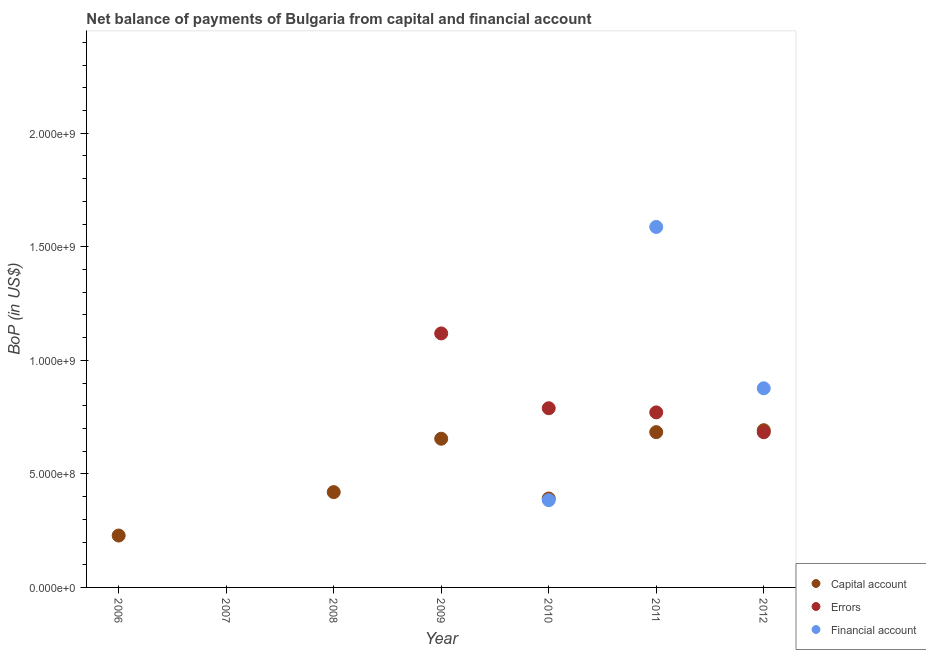Is the number of dotlines equal to the number of legend labels?
Give a very brief answer. No. What is the amount of financial account in 2011?
Provide a short and direct response. 1.59e+09. Across all years, what is the maximum amount of net capital account?
Your answer should be very brief. 6.92e+08. What is the total amount of financial account in the graph?
Ensure brevity in your answer.  2.85e+09. What is the difference between the amount of errors in 2009 and that in 2012?
Give a very brief answer. 4.35e+08. What is the difference between the amount of net capital account in 2011 and the amount of financial account in 2006?
Offer a very short reply. 6.84e+08. What is the average amount of financial account per year?
Your answer should be very brief. 4.07e+08. In the year 2010, what is the difference between the amount of net capital account and amount of errors?
Your response must be concise. -3.98e+08. What is the ratio of the amount of errors in 2009 to that in 2010?
Your answer should be compact. 1.42. Is the difference between the amount of errors in 2009 and 2010 greater than the difference between the amount of net capital account in 2009 and 2010?
Offer a very short reply. Yes. What is the difference between the highest and the second highest amount of financial account?
Keep it short and to the point. 7.10e+08. What is the difference between the highest and the lowest amount of net capital account?
Provide a succinct answer. 6.92e+08. Is the amount of net capital account strictly less than the amount of financial account over the years?
Your response must be concise. No. How many dotlines are there?
Make the answer very short. 3. Are the values on the major ticks of Y-axis written in scientific E-notation?
Keep it short and to the point. Yes. Does the graph contain any zero values?
Your answer should be compact. Yes. Does the graph contain grids?
Offer a very short reply. No. Where does the legend appear in the graph?
Keep it short and to the point. Bottom right. How many legend labels are there?
Provide a short and direct response. 3. How are the legend labels stacked?
Make the answer very short. Vertical. What is the title of the graph?
Your response must be concise. Net balance of payments of Bulgaria from capital and financial account. What is the label or title of the X-axis?
Make the answer very short. Year. What is the label or title of the Y-axis?
Offer a terse response. BoP (in US$). What is the BoP (in US$) in Capital account in 2006?
Give a very brief answer. 2.28e+08. What is the BoP (in US$) of Errors in 2006?
Provide a short and direct response. 0. What is the BoP (in US$) in Errors in 2007?
Provide a succinct answer. 0. What is the BoP (in US$) in Capital account in 2008?
Your answer should be compact. 4.20e+08. What is the BoP (in US$) of Capital account in 2009?
Your response must be concise. 6.55e+08. What is the BoP (in US$) in Errors in 2009?
Your response must be concise. 1.12e+09. What is the BoP (in US$) in Financial account in 2009?
Offer a terse response. 0. What is the BoP (in US$) in Capital account in 2010?
Offer a very short reply. 3.91e+08. What is the BoP (in US$) of Errors in 2010?
Ensure brevity in your answer.  7.89e+08. What is the BoP (in US$) of Financial account in 2010?
Offer a terse response. 3.84e+08. What is the BoP (in US$) in Capital account in 2011?
Give a very brief answer. 6.84e+08. What is the BoP (in US$) in Errors in 2011?
Your response must be concise. 7.71e+08. What is the BoP (in US$) in Financial account in 2011?
Give a very brief answer. 1.59e+09. What is the BoP (in US$) of Capital account in 2012?
Provide a short and direct response. 6.92e+08. What is the BoP (in US$) in Errors in 2012?
Keep it short and to the point. 6.83e+08. What is the BoP (in US$) in Financial account in 2012?
Offer a very short reply. 8.77e+08. Across all years, what is the maximum BoP (in US$) of Capital account?
Give a very brief answer. 6.92e+08. Across all years, what is the maximum BoP (in US$) of Errors?
Your answer should be compact. 1.12e+09. Across all years, what is the maximum BoP (in US$) in Financial account?
Offer a very short reply. 1.59e+09. Across all years, what is the minimum BoP (in US$) of Capital account?
Give a very brief answer. 0. What is the total BoP (in US$) of Capital account in the graph?
Offer a very short reply. 3.07e+09. What is the total BoP (in US$) in Errors in the graph?
Your answer should be compact. 3.36e+09. What is the total BoP (in US$) of Financial account in the graph?
Give a very brief answer. 2.85e+09. What is the difference between the BoP (in US$) in Capital account in 2006 and that in 2008?
Your answer should be very brief. -1.91e+08. What is the difference between the BoP (in US$) in Capital account in 2006 and that in 2009?
Provide a succinct answer. -4.26e+08. What is the difference between the BoP (in US$) in Capital account in 2006 and that in 2010?
Offer a very short reply. -1.63e+08. What is the difference between the BoP (in US$) of Capital account in 2006 and that in 2011?
Provide a succinct answer. -4.55e+08. What is the difference between the BoP (in US$) of Capital account in 2006 and that in 2012?
Provide a short and direct response. -4.64e+08. What is the difference between the BoP (in US$) of Capital account in 2008 and that in 2009?
Offer a very short reply. -2.35e+08. What is the difference between the BoP (in US$) in Capital account in 2008 and that in 2010?
Ensure brevity in your answer.  2.82e+07. What is the difference between the BoP (in US$) of Capital account in 2008 and that in 2011?
Make the answer very short. -2.64e+08. What is the difference between the BoP (in US$) in Capital account in 2008 and that in 2012?
Make the answer very short. -2.73e+08. What is the difference between the BoP (in US$) of Capital account in 2009 and that in 2010?
Offer a terse response. 2.63e+08. What is the difference between the BoP (in US$) in Errors in 2009 and that in 2010?
Keep it short and to the point. 3.29e+08. What is the difference between the BoP (in US$) in Capital account in 2009 and that in 2011?
Offer a very short reply. -2.90e+07. What is the difference between the BoP (in US$) in Errors in 2009 and that in 2011?
Keep it short and to the point. 3.48e+08. What is the difference between the BoP (in US$) of Capital account in 2009 and that in 2012?
Your answer should be very brief. -3.75e+07. What is the difference between the BoP (in US$) in Errors in 2009 and that in 2012?
Your response must be concise. 4.35e+08. What is the difference between the BoP (in US$) of Capital account in 2010 and that in 2011?
Provide a succinct answer. -2.92e+08. What is the difference between the BoP (in US$) of Errors in 2010 and that in 2011?
Your answer should be compact. 1.83e+07. What is the difference between the BoP (in US$) in Financial account in 2010 and that in 2011?
Ensure brevity in your answer.  -1.20e+09. What is the difference between the BoP (in US$) of Capital account in 2010 and that in 2012?
Provide a short and direct response. -3.01e+08. What is the difference between the BoP (in US$) of Errors in 2010 and that in 2012?
Keep it short and to the point. 1.06e+08. What is the difference between the BoP (in US$) of Financial account in 2010 and that in 2012?
Provide a short and direct response. -4.93e+08. What is the difference between the BoP (in US$) of Capital account in 2011 and that in 2012?
Your response must be concise. -8.50e+06. What is the difference between the BoP (in US$) of Errors in 2011 and that in 2012?
Your response must be concise. 8.74e+07. What is the difference between the BoP (in US$) in Financial account in 2011 and that in 2012?
Offer a very short reply. 7.10e+08. What is the difference between the BoP (in US$) of Capital account in 2006 and the BoP (in US$) of Errors in 2009?
Give a very brief answer. -8.90e+08. What is the difference between the BoP (in US$) of Capital account in 2006 and the BoP (in US$) of Errors in 2010?
Your response must be concise. -5.61e+08. What is the difference between the BoP (in US$) of Capital account in 2006 and the BoP (in US$) of Financial account in 2010?
Offer a very short reply. -1.56e+08. What is the difference between the BoP (in US$) in Capital account in 2006 and the BoP (in US$) in Errors in 2011?
Your response must be concise. -5.42e+08. What is the difference between the BoP (in US$) of Capital account in 2006 and the BoP (in US$) of Financial account in 2011?
Offer a very short reply. -1.36e+09. What is the difference between the BoP (in US$) of Capital account in 2006 and the BoP (in US$) of Errors in 2012?
Make the answer very short. -4.55e+08. What is the difference between the BoP (in US$) in Capital account in 2006 and the BoP (in US$) in Financial account in 2012?
Ensure brevity in your answer.  -6.48e+08. What is the difference between the BoP (in US$) in Capital account in 2008 and the BoP (in US$) in Errors in 2009?
Provide a succinct answer. -6.99e+08. What is the difference between the BoP (in US$) of Capital account in 2008 and the BoP (in US$) of Errors in 2010?
Ensure brevity in your answer.  -3.69e+08. What is the difference between the BoP (in US$) in Capital account in 2008 and the BoP (in US$) in Financial account in 2010?
Keep it short and to the point. 3.55e+07. What is the difference between the BoP (in US$) in Capital account in 2008 and the BoP (in US$) in Errors in 2011?
Offer a very short reply. -3.51e+08. What is the difference between the BoP (in US$) in Capital account in 2008 and the BoP (in US$) in Financial account in 2011?
Ensure brevity in your answer.  -1.17e+09. What is the difference between the BoP (in US$) in Capital account in 2008 and the BoP (in US$) in Errors in 2012?
Your response must be concise. -2.64e+08. What is the difference between the BoP (in US$) in Capital account in 2008 and the BoP (in US$) in Financial account in 2012?
Make the answer very short. -4.57e+08. What is the difference between the BoP (in US$) of Capital account in 2009 and the BoP (in US$) of Errors in 2010?
Make the answer very short. -1.34e+08. What is the difference between the BoP (in US$) in Capital account in 2009 and the BoP (in US$) in Financial account in 2010?
Your answer should be compact. 2.71e+08. What is the difference between the BoP (in US$) in Errors in 2009 and the BoP (in US$) in Financial account in 2010?
Give a very brief answer. 7.34e+08. What is the difference between the BoP (in US$) in Capital account in 2009 and the BoP (in US$) in Errors in 2011?
Offer a very short reply. -1.16e+08. What is the difference between the BoP (in US$) in Capital account in 2009 and the BoP (in US$) in Financial account in 2011?
Provide a succinct answer. -9.32e+08. What is the difference between the BoP (in US$) in Errors in 2009 and the BoP (in US$) in Financial account in 2011?
Your answer should be very brief. -4.69e+08. What is the difference between the BoP (in US$) in Capital account in 2009 and the BoP (in US$) in Errors in 2012?
Ensure brevity in your answer.  -2.86e+07. What is the difference between the BoP (in US$) in Capital account in 2009 and the BoP (in US$) in Financial account in 2012?
Your answer should be compact. -2.22e+08. What is the difference between the BoP (in US$) of Errors in 2009 and the BoP (in US$) of Financial account in 2012?
Make the answer very short. 2.42e+08. What is the difference between the BoP (in US$) of Capital account in 2010 and the BoP (in US$) of Errors in 2011?
Provide a short and direct response. -3.79e+08. What is the difference between the BoP (in US$) of Capital account in 2010 and the BoP (in US$) of Financial account in 2011?
Offer a terse response. -1.20e+09. What is the difference between the BoP (in US$) of Errors in 2010 and the BoP (in US$) of Financial account in 2011?
Offer a terse response. -7.98e+08. What is the difference between the BoP (in US$) in Capital account in 2010 and the BoP (in US$) in Errors in 2012?
Offer a very short reply. -2.92e+08. What is the difference between the BoP (in US$) in Capital account in 2010 and the BoP (in US$) in Financial account in 2012?
Your answer should be very brief. -4.85e+08. What is the difference between the BoP (in US$) in Errors in 2010 and the BoP (in US$) in Financial account in 2012?
Offer a terse response. -8.78e+07. What is the difference between the BoP (in US$) in Capital account in 2011 and the BoP (in US$) in Errors in 2012?
Your answer should be compact. 4.59e+05. What is the difference between the BoP (in US$) of Capital account in 2011 and the BoP (in US$) of Financial account in 2012?
Provide a short and direct response. -1.93e+08. What is the difference between the BoP (in US$) of Errors in 2011 and the BoP (in US$) of Financial account in 2012?
Offer a terse response. -1.06e+08. What is the average BoP (in US$) of Capital account per year?
Offer a terse response. 4.39e+08. What is the average BoP (in US$) of Errors per year?
Your response must be concise. 4.80e+08. What is the average BoP (in US$) of Financial account per year?
Offer a terse response. 4.07e+08. In the year 2009, what is the difference between the BoP (in US$) in Capital account and BoP (in US$) in Errors?
Offer a very short reply. -4.64e+08. In the year 2010, what is the difference between the BoP (in US$) in Capital account and BoP (in US$) in Errors?
Offer a very short reply. -3.98e+08. In the year 2010, what is the difference between the BoP (in US$) of Capital account and BoP (in US$) of Financial account?
Provide a short and direct response. 7.31e+06. In the year 2010, what is the difference between the BoP (in US$) in Errors and BoP (in US$) in Financial account?
Offer a terse response. 4.05e+08. In the year 2011, what is the difference between the BoP (in US$) of Capital account and BoP (in US$) of Errors?
Provide a succinct answer. -8.70e+07. In the year 2011, what is the difference between the BoP (in US$) in Capital account and BoP (in US$) in Financial account?
Offer a terse response. -9.03e+08. In the year 2011, what is the difference between the BoP (in US$) of Errors and BoP (in US$) of Financial account?
Offer a terse response. -8.16e+08. In the year 2012, what is the difference between the BoP (in US$) of Capital account and BoP (in US$) of Errors?
Your response must be concise. 8.96e+06. In the year 2012, what is the difference between the BoP (in US$) of Capital account and BoP (in US$) of Financial account?
Provide a short and direct response. -1.85e+08. In the year 2012, what is the difference between the BoP (in US$) of Errors and BoP (in US$) of Financial account?
Give a very brief answer. -1.94e+08. What is the ratio of the BoP (in US$) of Capital account in 2006 to that in 2008?
Give a very brief answer. 0.54. What is the ratio of the BoP (in US$) in Capital account in 2006 to that in 2009?
Your answer should be very brief. 0.35. What is the ratio of the BoP (in US$) in Capital account in 2006 to that in 2010?
Provide a short and direct response. 0.58. What is the ratio of the BoP (in US$) in Capital account in 2006 to that in 2011?
Your response must be concise. 0.33. What is the ratio of the BoP (in US$) of Capital account in 2006 to that in 2012?
Provide a succinct answer. 0.33. What is the ratio of the BoP (in US$) of Capital account in 2008 to that in 2009?
Your answer should be very brief. 0.64. What is the ratio of the BoP (in US$) in Capital account in 2008 to that in 2010?
Provide a short and direct response. 1.07. What is the ratio of the BoP (in US$) of Capital account in 2008 to that in 2011?
Keep it short and to the point. 0.61. What is the ratio of the BoP (in US$) of Capital account in 2008 to that in 2012?
Your answer should be compact. 0.61. What is the ratio of the BoP (in US$) of Capital account in 2009 to that in 2010?
Keep it short and to the point. 1.67. What is the ratio of the BoP (in US$) of Errors in 2009 to that in 2010?
Make the answer very short. 1.42. What is the ratio of the BoP (in US$) of Capital account in 2009 to that in 2011?
Make the answer very short. 0.96. What is the ratio of the BoP (in US$) in Errors in 2009 to that in 2011?
Offer a very short reply. 1.45. What is the ratio of the BoP (in US$) of Capital account in 2009 to that in 2012?
Provide a short and direct response. 0.95. What is the ratio of the BoP (in US$) of Errors in 2009 to that in 2012?
Offer a very short reply. 1.64. What is the ratio of the BoP (in US$) in Capital account in 2010 to that in 2011?
Ensure brevity in your answer.  0.57. What is the ratio of the BoP (in US$) of Errors in 2010 to that in 2011?
Provide a succinct answer. 1.02. What is the ratio of the BoP (in US$) of Financial account in 2010 to that in 2011?
Provide a short and direct response. 0.24. What is the ratio of the BoP (in US$) in Capital account in 2010 to that in 2012?
Your answer should be compact. 0.57. What is the ratio of the BoP (in US$) of Errors in 2010 to that in 2012?
Make the answer very short. 1.15. What is the ratio of the BoP (in US$) of Financial account in 2010 to that in 2012?
Ensure brevity in your answer.  0.44. What is the ratio of the BoP (in US$) in Capital account in 2011 to that in 2012?
Ensure brevity in your answer.  0.99. What is the ratio of the BoP (in US$) in Errors in 2011 to that in 2012?
Your response must be concise. 1.13. What is the ratio of the BoP (in US$) in Financial account in 2011 to that in 2012?
Ensure brevity in your answer.  1.81. What is the difference between the highest and the second highest BoP (in US$) of Capital account?
Your response must be concise. 8.50e+06. What is the difference between the highest and the second highest BoP (in US$) of Errors?
Offer a terse response. 3.29e+08. What is the difference between the highest and the second highest BoP (in US$) of Financial account?
Provide a short and direct response. 7.10e+08. What is the difference between the highest and the lowest BoP (in US$) in Capital account?
Ensure brevity in your answer.  6.92e+08. What is the difference between the highest and the lowest BoP (in US$) in Errors?
Offer a very short reply. 1.12e+09. What is the difference between the highest and the lowest BoP (in US$) in Financial account?
Give a very brief answer. 1.59e+09. 